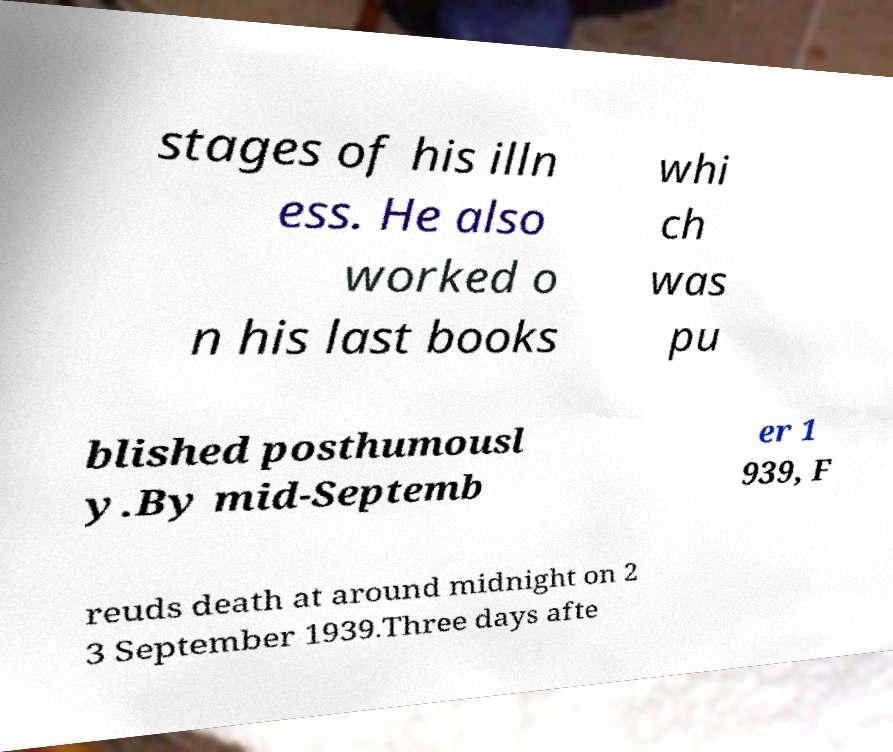What messages or text are displayed in this image? I need them in a readable, typed format. stages of his illn ess. He also worked o n his last books whi ch was pu blished posthumousl y.By mid-Septemb er 1 939, F reuds death at around midnight on 2 3 September 1939.Three days afte 